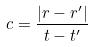Convert formula to latex. <formula><loc_0><loc_0><loc_500><loc_500>c = \frac { | r - r ^ { \prime } | } { t - t ^ { \prime } }</formula> 